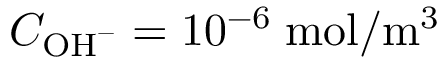Convert formula to latex. <formula><loc_0><loc_0><loc_500><loc_500>C _ { O H ^ { - } } = 1 0 ^ { - 6 } \, m o l / m ^ { 3 }</formula> 